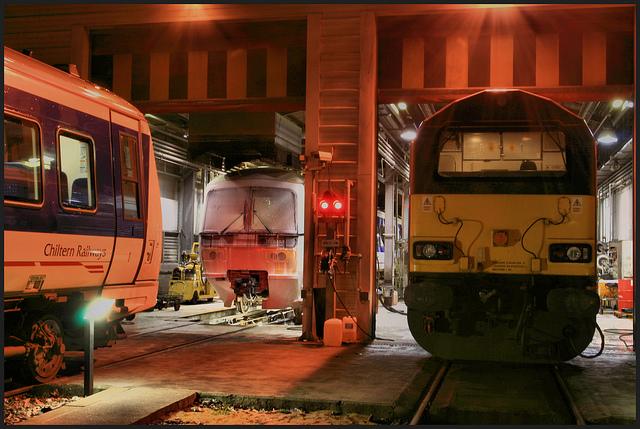Are these trains in motion?
Concise answer only. No. How many trains are there?
Give a very brief answer. 3. What is the name on the left most train?
Be succinct. Chilean railways. 